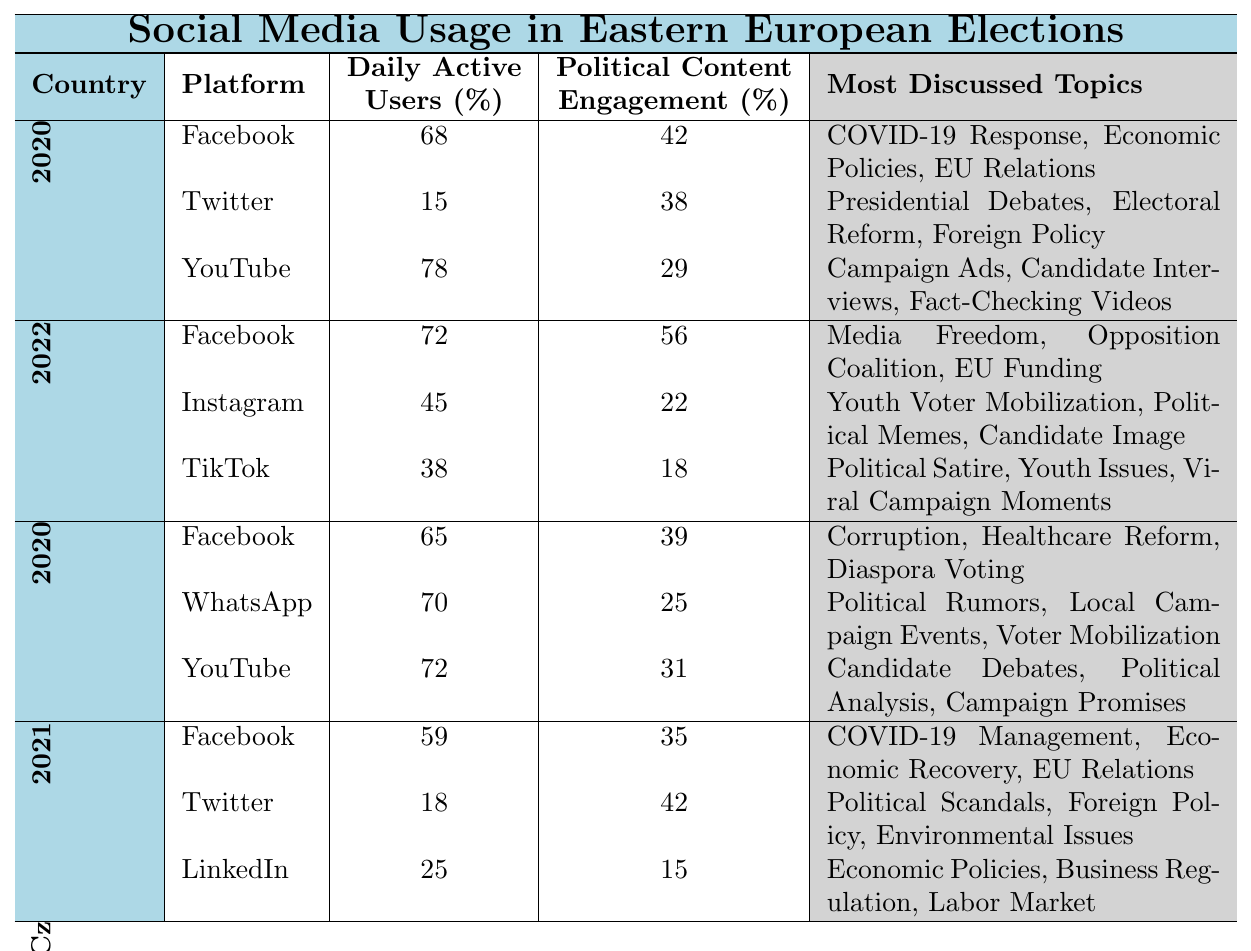What country had the highest percentage of daily active users on YouTube during their election? Looking at the table, Romania had 72% daily active users on YouTube, which is the highest compared to Poland (78%), Hungary (38%), and Czech Republic (25%)
Answer: Romania Which social media platform had the lowest political content engagement in Hungary? The platform with the lowest political content engagement in Hungary is TikTok, with 18%. Facebook had 56% and Instagram had 22%
Answer: TikTok What is the average daily active users percentage for Facebook across all countries? The daily active users percentages for Facebook are 68% (Poland), 72% (Hungary), 65% (Romania), and 59% (Czech Republic). To find the average: (68 + 72 + 65 + 59) / 4 = 66
Answer: 66 Did Instagram have a higher daily active user percentage than Twitter in Poland? In Poland, Instagram is not listed, but Twitter had a daily active user percentage of 15%. Thus, no comparison can be made with Instagram
Answer: No Which country and platform had the highest political content engagement rate? The highest political content engagement rate is 56% from Facebook in Hungary. Other engagement rates are lower (42% in Facebook in Poland, etc.)
Answer: Hungary, Facebook What is the total political content engagement percentage for all platforms in the Czech Republic? In the Czech Republic, the political content engagement percentages are: Facebook (35%), Twitter (42%), and LinkedIn (15%). The total is 35 + 42 + 15 = 92
Answer: 92 How many social media platforms had more than 40% daily active users in Romania? In Romania, Facebook (65%), WhatsApp (70%), and YouTube (72%) all had more than 40% daily active users. This totals three platforms
Answer: Three Was the political content engagement on YouTube in Poland higher or lower than that for TikTok in Hungary? In Poland, the political content engagement on YouTube is 29%, while in Hungary, TikTok's engagement is 18%. Thus, it was higher in Poland
Answer: Higher 